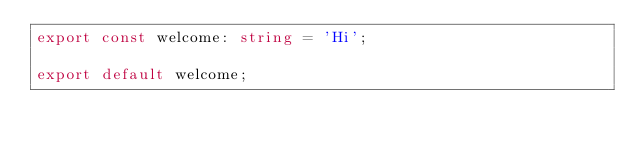<code> <loc_0><loc_0><loc_500><loc_500><_TypeScript_>export const welcome: string = 'Hi';

export default welcome;
</code> 